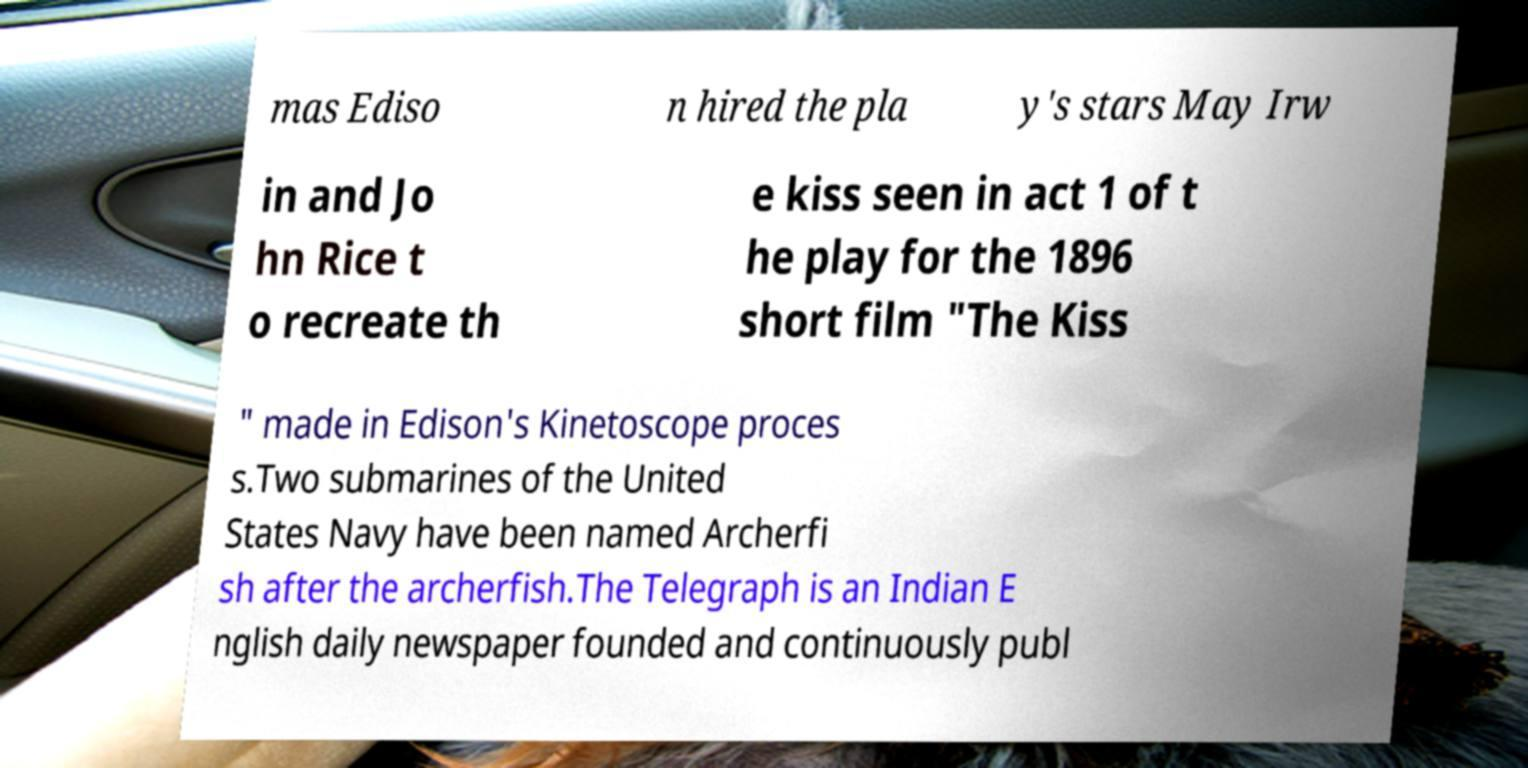For documentation purposes, I need the text within this image transcribed. Could you provide that? mas Ediso n hired the pla y's stars May Irw in and Jo hn Rice t o recreate th e kiss seen in act 1 of t he play for the 1896 short film "The Kiss " made in Edison's Kinetoscope proces s.Two submarines of the United States Navy have been named Archerfi sh after the archerfish.The Telegraph is an Indian E nglish daily newspaper founded and continuously publ 